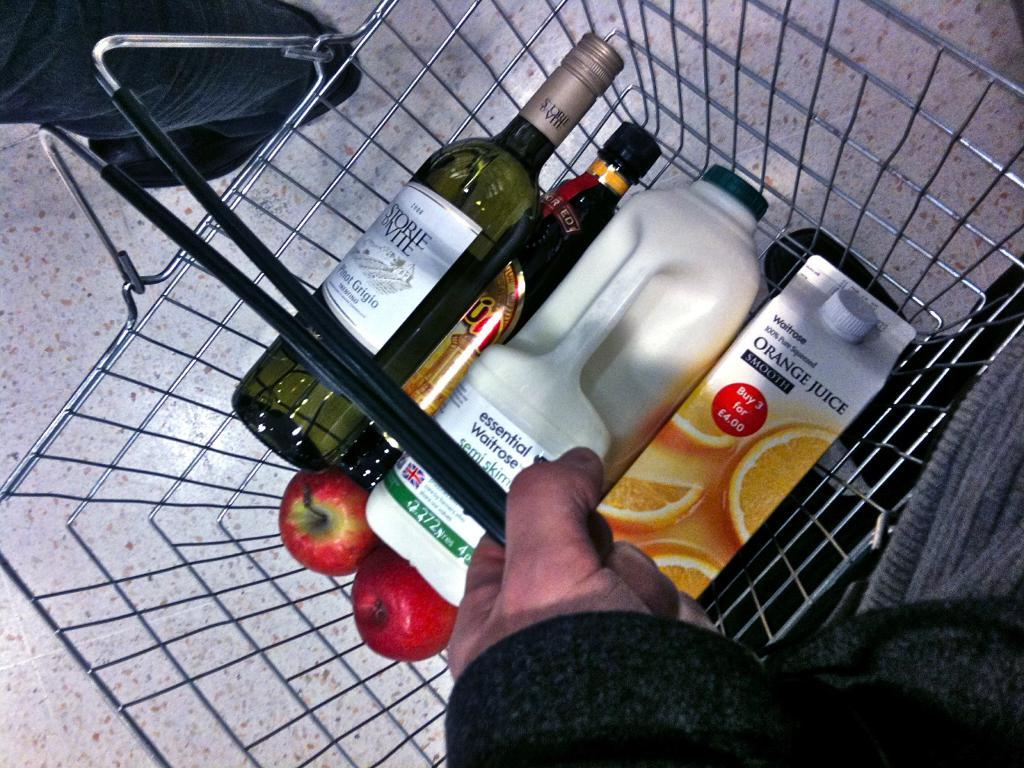<image>
Write a terse but informative summary of the picture. A person has wine, orange juice, milk, and apples in a shopping basket. 